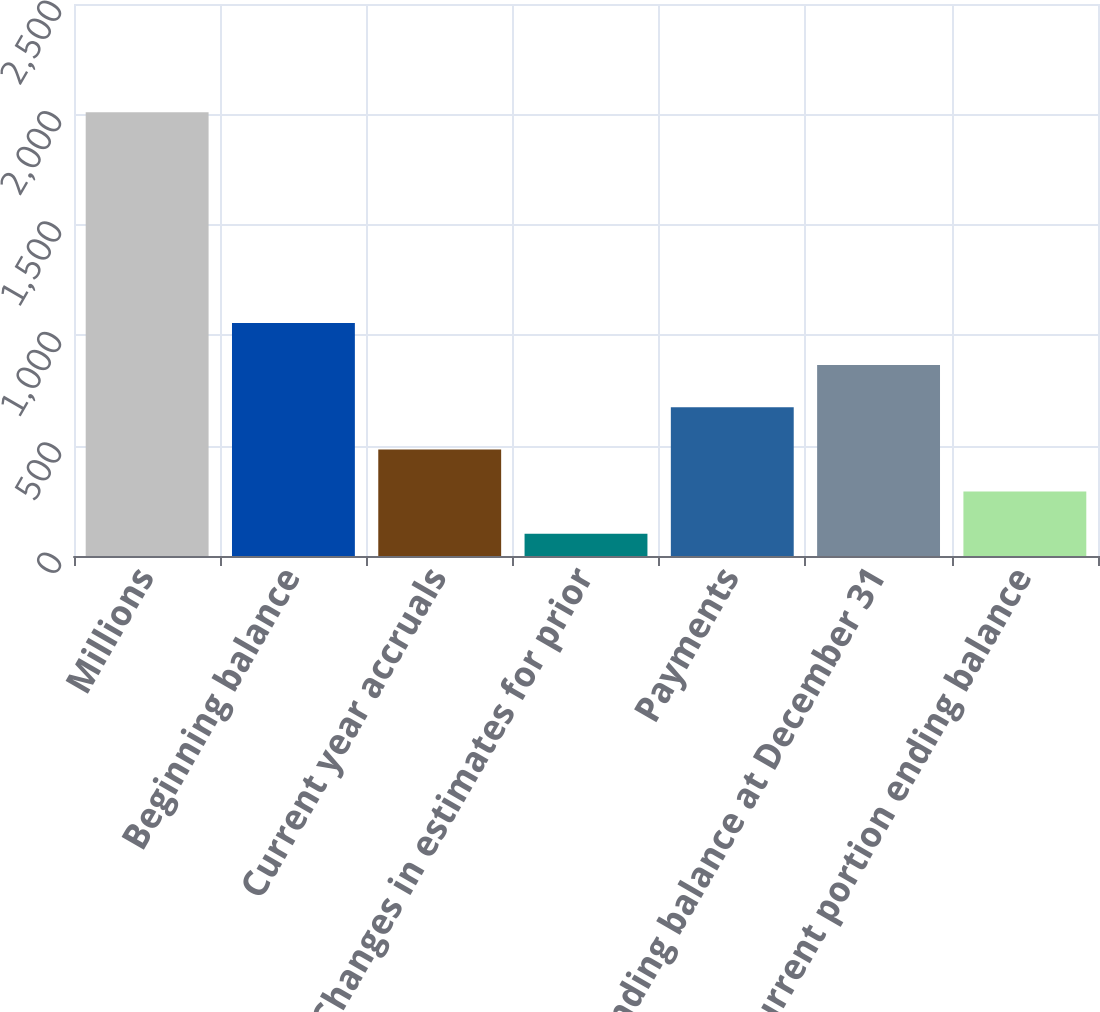Convert chart. <chart><loc_0><loc_0><loc_500><loc_500><bar_chart><fcel>Millions<fcel>Beginning balance<fcel>Current year accruals<fcel>Changes in estimates for prior<fcel>Payments<fcel>Ending balance at December 31<fcel>Current portion ending balance<nl><fcel>2010<fcel>1055.5<fcel>482.8<fcel>101<fcel>673.7<fcel>864.6<fcel>291.9<nl></chart> 